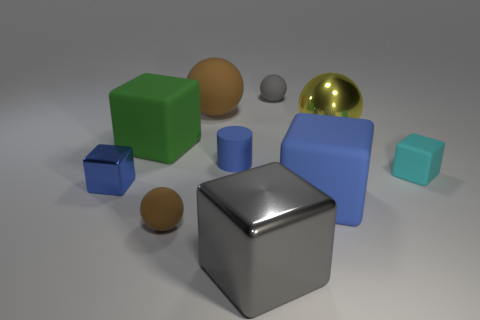Subtract all big shiny cubes. How many cubes are left? 4 Subtract all gray cubes. How many cubes are left? 4 Subtract all purple cubes. Subtract all yellow balls. How many cubes are left? 5 Subtract all cylinders. How many objects are left? 9 Subtract all yellow cubes. Subtract all tiny matte objects. How many objects are left? 6 Add 6 yellow things. How many yellow things are left? 7 Add 7 gray cubes. How many gray cubes exist? 8 Subtract 0 yellow cylinders. How many objects are left? 10 